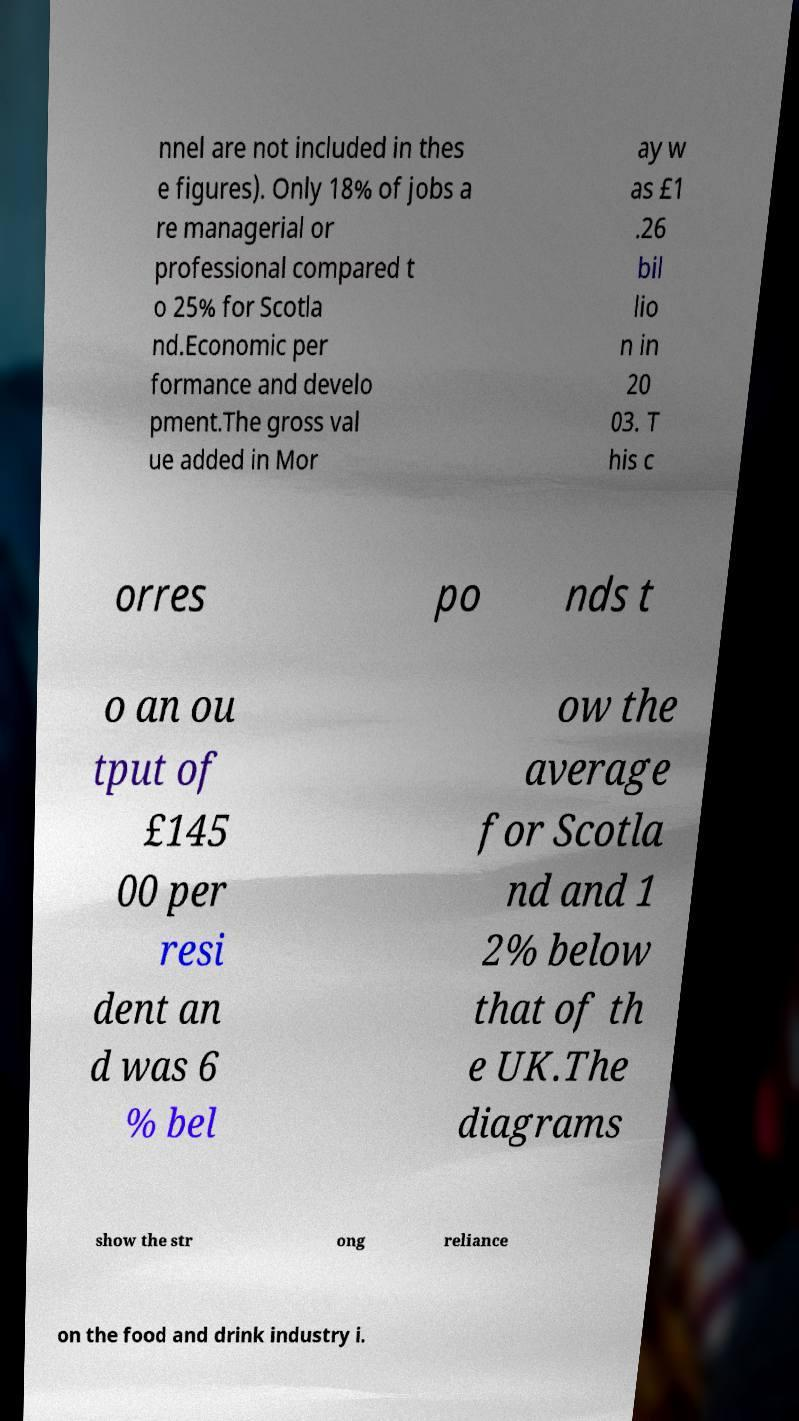Could you assist in decoding the text presented in this image and type it out clearly? nnel are not included in thes e figures). Only 18% of jobs a re managerial or professional compared t o 25% for Scotla nd.Economic per formance and develo pment.The gross val ue added in Mor ay w as £1 .26 bil lio n in 20 03. T his c orres po nds t o an ou tput of £145 00 per resi dent an d was 6 % bel ow the average for Scotla nd and 1 2% below that of th e UK.The diagrams show the str ong reliance on the food and drink industry i. 